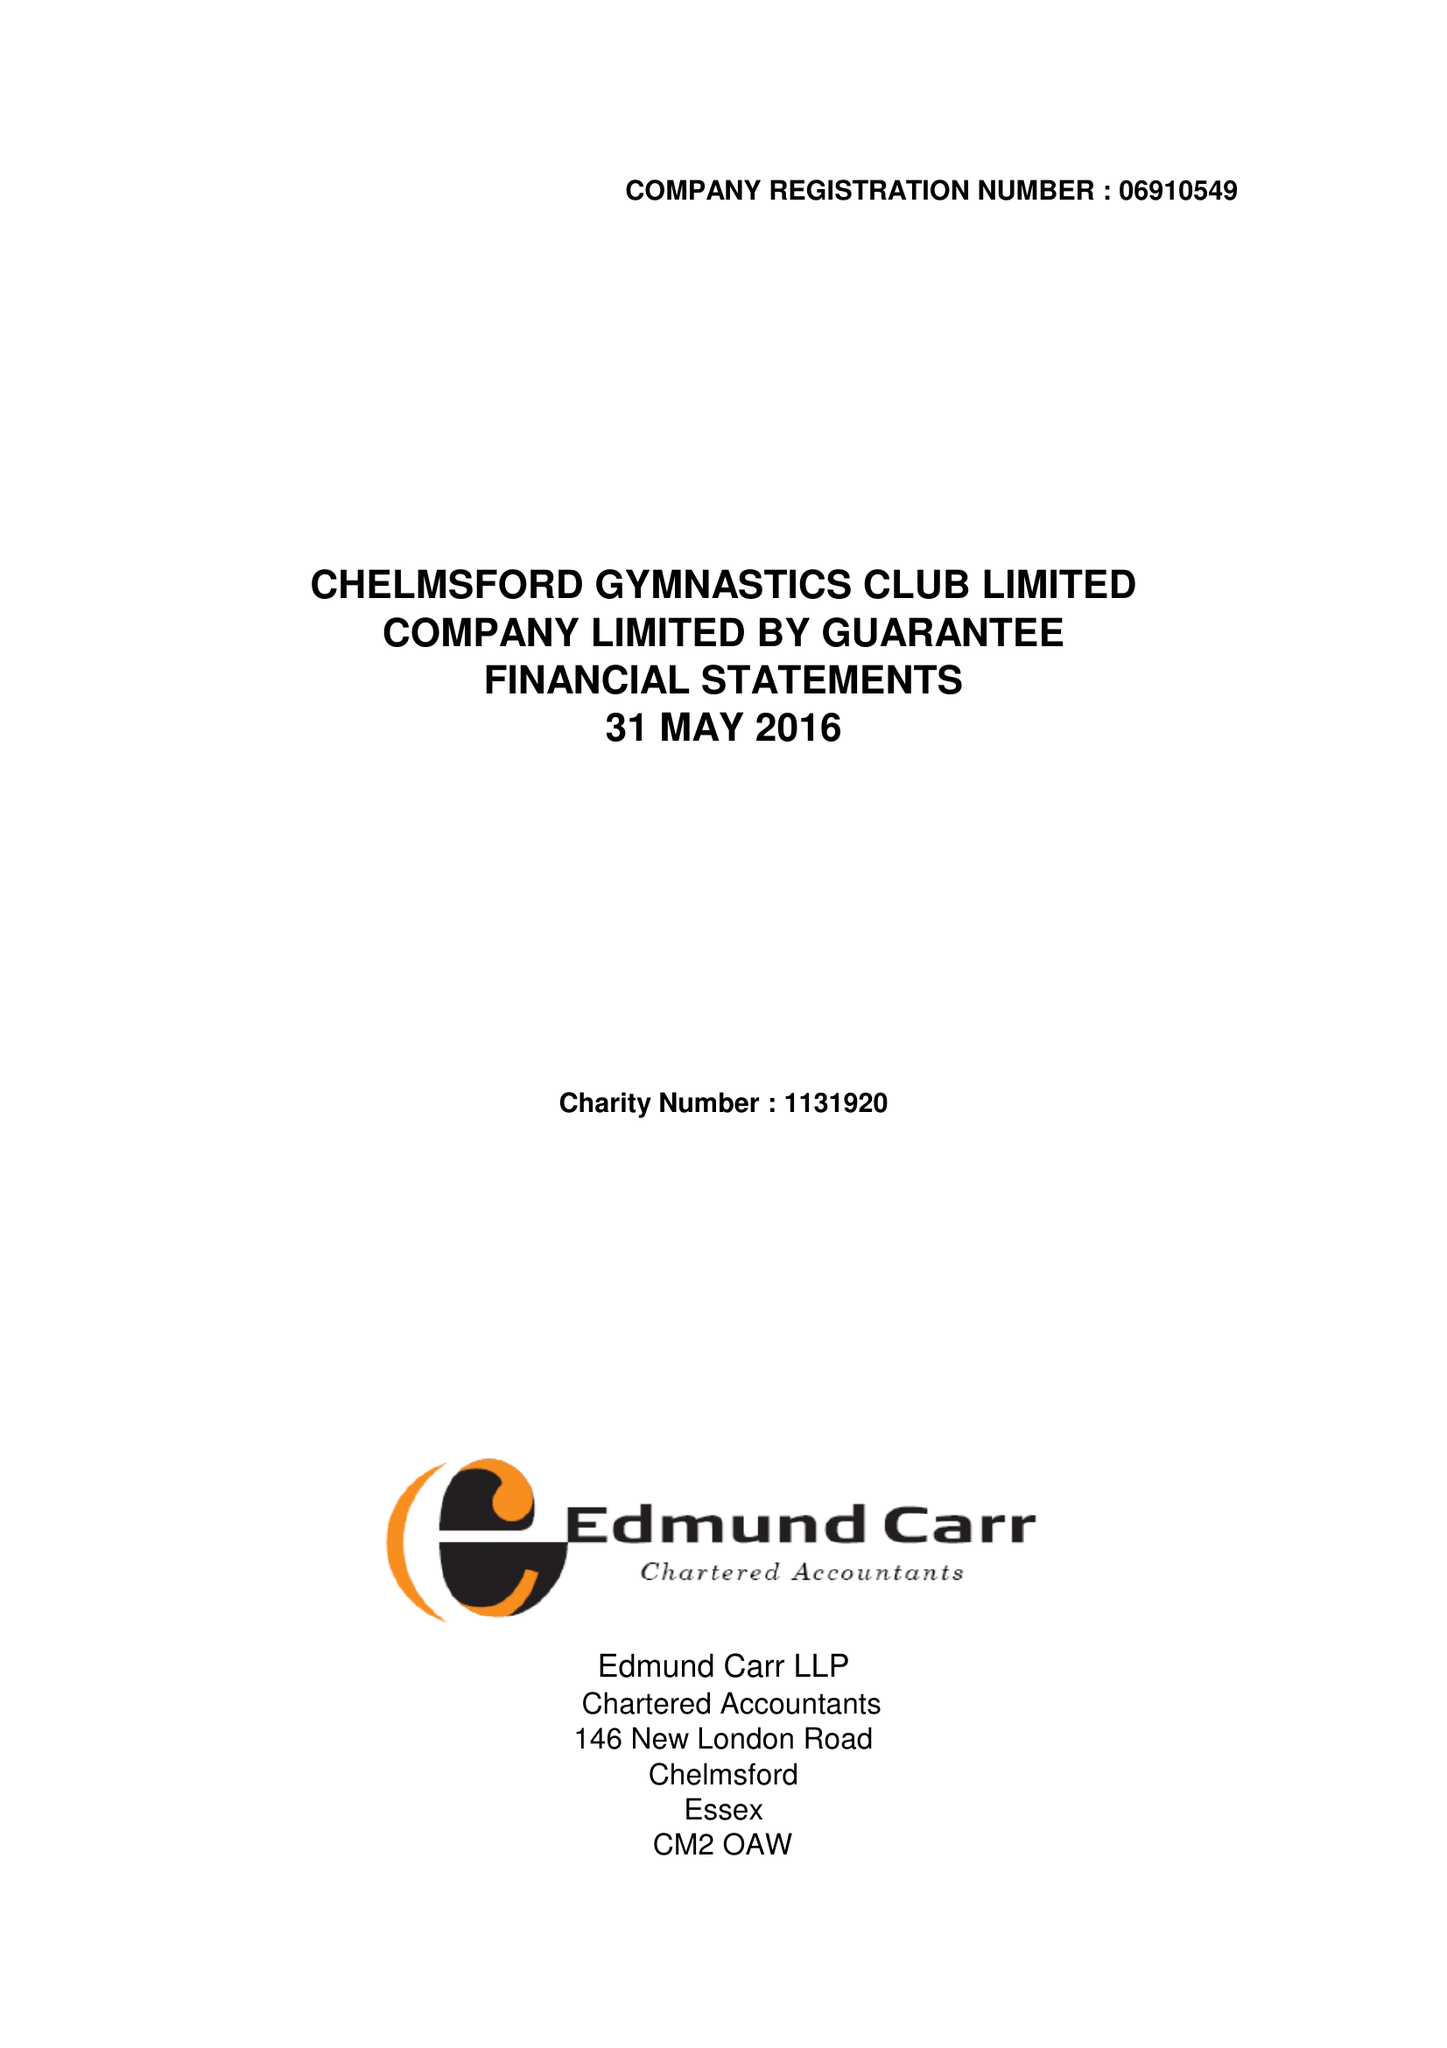What is the value for the address__post_town?
Answer the question using a single word or phrase. CHELMSFORD 